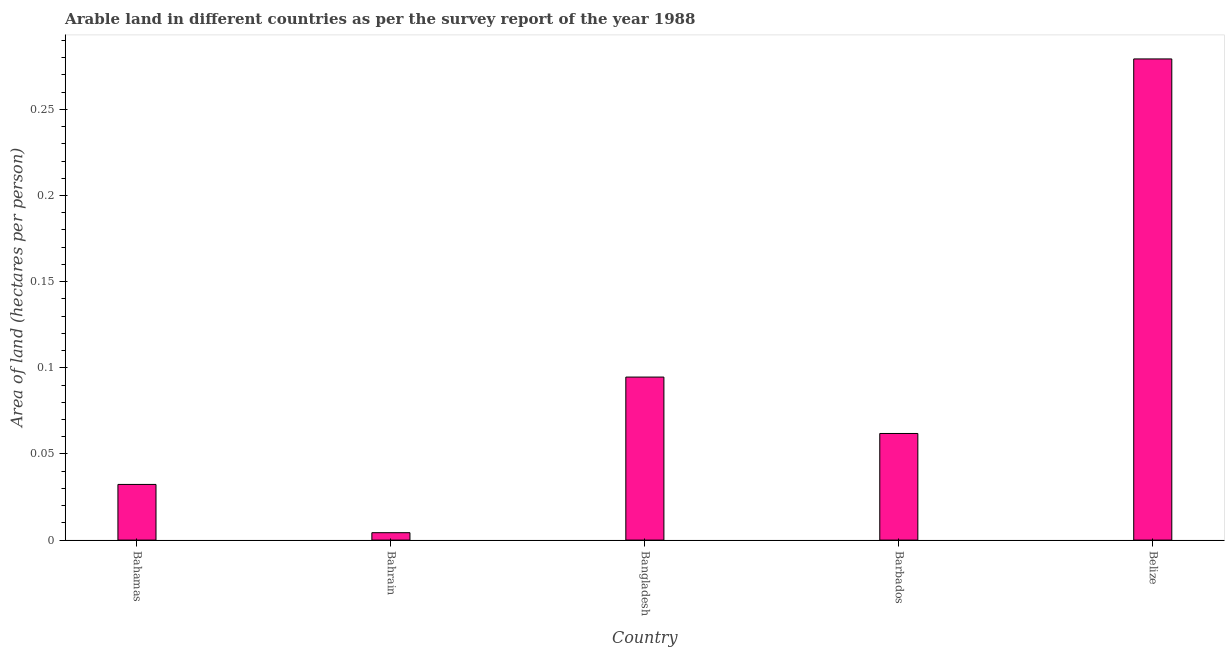Does the graph contain any zero values?
Your response must be concise. No. Does the graph contain grids?
Ensure brevity in your answer.  No. What is the title of the graph?
Your answer should be compact. Arable land in different countries as per the survey report of the year 1988. What is the label or title of the Y-axis?
Your answer should be very brief. Area of land (hectares per person). What is the area of arable land in Bahamas?
Offer a very short reply. 0.03. Across all countries, what is the maximum area of arable land?
Offer a terse response. 0.28. Across all countries, what is the minimum area of arable land?
Your answer should be compact. 0. In which country was the area of arable land maximum?
Offer a terse response. Belize. In which country was the area of arable land minimum?
Offer a very short reply. Bahrain. What is the sum of the area of arable land?
Keep it short and to the point. 0.47. What is the difference between the area of arable land in Bahamas and Bahrain?
Your answer should be very brief. 0.03. What is the average area of arable land per country?
Make the answer very short. 0.09. What is the median area of arable land?
Keep it short and to the point. 0.06. In how many countries, is the area of arable land greater than 0.24 hectares per person?
Give a very brief answer. 1. What is the ratio of the area of arable land in Bangladesh to that in Barbados?
Make the answer very short. 1.53. Is the area of arable land in Bahamas less than that in Bahrain?
Keep it short and to the point. No. Is the difference between the area of arable land in Bahamas and Barbados greater than the difference between any two countries?
Make the answer very short. No. What is the difference between the highest and the second highest area of arable land?
Offer a very short reply. 0.18. Is the sum of the area of arable land in Bangladesh and Barbados greater than the maximum area of arable land across all countries?
Offer a terse response. No. What is the difference between the highest and the lowest area of arable land?
Offer a terse response. 0.27. In how many countries, is the area of arable land greater than the average area of arable land taken over all countries?
Make the answer very short. 2. How many countries are there in the graph?
Offer a very short reply. 5. Are the values on the major ticks of Y-axis written in scientific E-notation?
Offer a very short reply. No. What is the Area of land (hectares per person) of Bahamas?
Provide a short and direct response. 0.03. What is the Area of land (hectares per person) in Bahrain?
Give a very brief answer. 0. What is the Area of land (hectares per person) in Bangladesh?
Offer a terse response. 0.09. What is the Area of land (hectares per person) in Barbados?
Provide a succinct answer. 0.06. What is the Area of land (hectares per person) in Belize?
Give a very brief answer. 0.28. What is the difference between the Area of land (hectares per person) in Bahamas and Bahrain?
Provide a succinct answer. 0.03. What is the difference between the Area of land (hectares per person) in Bahamas and Bangladesh?
Offer a terse response. -0.06. What is the difference between the Area of land (hectares per person) in Bahamas and Barbados?
Offer a terse response. -0.03. What is the difference between the Area of land (hectares per person) in Bahamas and Belize?
Keep it short and to the point. -0.25. What is the difference between the Area of land (hectares per person) in Bahrain and Bangladesh?
Your answer should be very brief. -0.09. What is the difference between the Area of land (hectares per person) in Bahrain and Barbados?
Provide a succinct answer. -0.06. What is the difference between the Area of land (hectares per person) in Bahrain and Belize?
Make the answer very short. -0.27. What is the difference between the Area of land (hectares per person) in Bangladesh and Barbados?
Provide a succinct answer. 0.03. What is the difference between the Area of land (hectares per person) in Bangladesh and Belize?
Keep it short and to the point. -0.18. What is the difference between the Area of land (hectares per person) in Barbados and Belize?
Your answer should be very brief. -0.22. What is the ratio of the Area of land (hectares per person) in Bahamas to that in Bahrain?
Make the answer very short. 7.52. What is the ratio of the Area of land (hectares per person) in Bahamas to that in Bangladesh?
Keep it short and to the point. 0.34. What is the ratio of the Area of land (hectares per person) in Bahamas to that in Barbados?
Offer a terse response. 0.52. What is the ratio of the Area of land (hectares per person) in Bahamas to that in Belize?
Keep it short and to the point. 0.12. What is the ratio of the Area of land (hectares per person) in Bahrain to that in Bangladesh?
Provide a short and direct response. 0.04. What is the ratio of the Area of land (hectares per person) in Bahrain to that in Barbados?
Provide a succinct answer. 0.07. What is the ratio of the Area of land (hectares per person) in Bahrain to that in Belize?
Make the answer very short. 0.01. What is the ratio of the Area of land (hectares per person) in Bangladesh to that in Barbados?
Offer a very short reply. 1.53. What is the ratio of the Area of land (hectares per person) in Bangladesh to that in Belize?
Offer a terse response. 0.34. What is the ratio of the Area of land (hectares per person) in Barbados to that in Belize?
Your answer should be very brief. 0.22. 